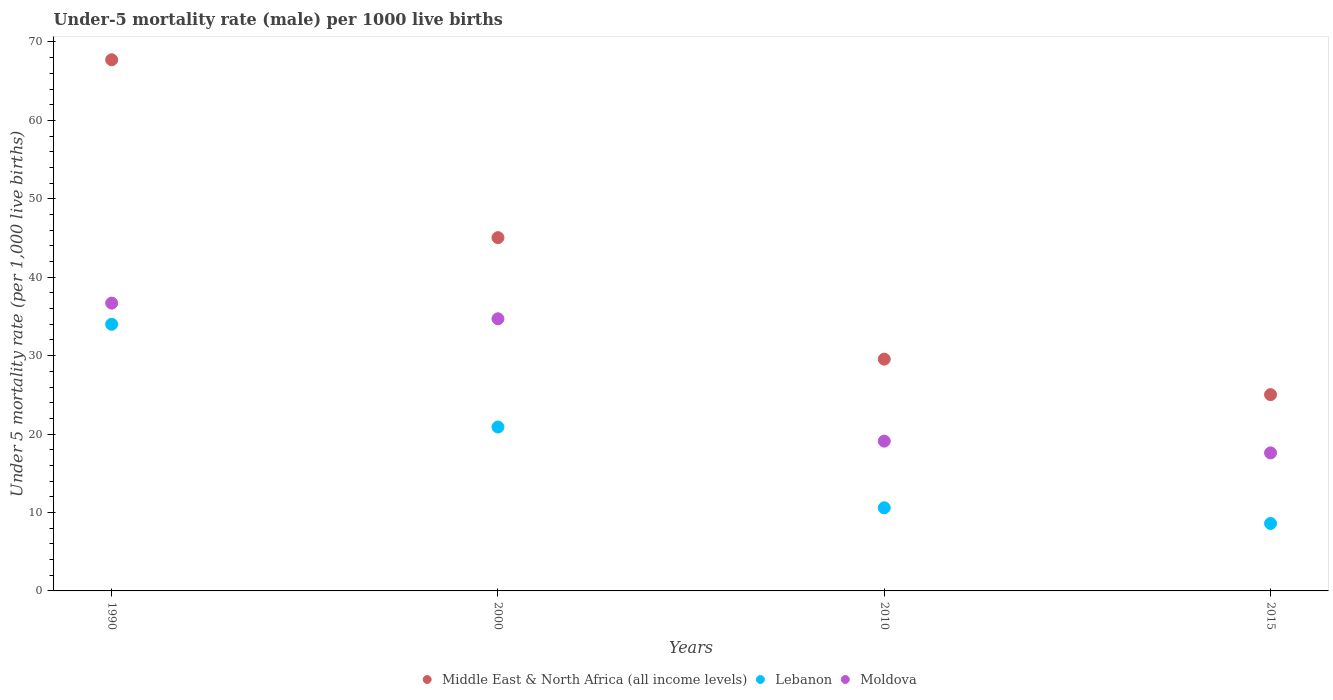What is the under-five mortality rate in Lebanon in 2010?
Your answer should be very brief. 10.6. Across all years, what is the maximum under-five mortality rate in Middle East & North Africa (all income levels)?
Offer a very short reply. 67.73. In which year was the under-five mortality rate in Lebanon minimum?
Your answer should be very brief. 2015. What is the total under-five mortality rate in Middle East & North Africa (all income levels) in the graph?
Your answer should be compact. 167.36. What is the difference between the under-five mortality rate in Lebanon in 1990 and that in 2015?
Your answer should be very brief. 25.4. What is the difference between the under-five mortality rate in Lebanon in 1990 and the under-five mortality rate in Moldova in 2000?
Your response must be concise. -0.7. What is the average under-five mortality rate in Middle East & North Africa (all income levels) per year?
Your answer should be compact. 41.84. In the year 2010, what is the difference between the under-five mortality rate in Lebanon and under-five mortality rate in Middle East & North Africa (all income levels)?
Make the answer very short. -18.96. What is the ratio of the under-five mortality rate in Middle East & North Africa (all income levels) in 1990 to that in 2010?
Make the answer very short. 2.29. Is the difference between the under-five mortality rate in Lebanon in 2010 and 2015 greater than the difference between the under-five mortality rate in Middle East & North Africa (all income levels) in 2010 and 2015?
Your response must be concise. No. What is the difference between the highest and the second highest under-five mortality rate in Moldova?
Provide a succinct answer. 2. What is the difference between the highest and the lowest under-five mortality rate in Moldova?
Offer a terse response. 19.1. Is the sum of the under-five mortality rate in Moldova in 1990 and 2010 greater than the maximum under-five mortality rate in Middle East & North Africa (all income levels) across all years?
Give a very brief answer. No. Is it the case that in every year, the sum of the under-five mortality rate in Moldova and under-five mortality rate in Lebanon  is greater than the under-five mortality rate in Middle East & North Africa (all income levels)?
Keep it short and to the point. Yes. Is the under-five mortality rate in Middle East & North Africa (all income levels) strictly less than the under-five mortality rate in Moldova over the years?
Offer a terse response. No. How many dotlines are there?
Your answer should be compact. 3. What is the difference between two consecutive major ticks on the Y-axis?
Keep it short and to the point. 10. Does the graph contain grids?
Provide a succinct answer. No. What is the title of the graph?
Your response must be concise. Under-5 mortality rate (male) per 1000 live births. Does "Angola" appear as one of the legend labels in the graph?
Make the answer very short. No. What is the label or title of the X-axis?
Make the answer very short. Years. What is the label or title of the Y-axis?
Provide a succinct answer. Under 5 mortality rate (per 1,0 live births). What is the Under 5 mortality rate (per 1,000 live births) of Middle East & North Africa (all income levels) in 1990?
Provide a succinct answer. 67.73. What is the Under 5 mortality rate (per 1,000 live births) of Lebanon in 1990?
Make the answer very short. 34. What is the Under 5 mortality rate (per 1,000 live births) of Moldova in 1990?
Ensure brevity in your answer.  36.7. What is the Under 5 mortality rate (per 1,000 live births) in Middle East & North Africa (all income levels) in 2000?
Your response must be concise. 45.05. What is the Under 5 mortality rate (per 1,000 live births) in Lebanon in 2000?
Provide a short and direct response. 20.9. What is the Under 5 mortality rate (per 1,000 live births) of Moldova in 2000?
Your answer should be very brief. 34.7. What is the Under 5 mortality rate (per 1,000 live births) of Middle East & North Africa (all income levels) in 2010?
Give a very brief answer. 29.56. What is the Under 5 mortality rate (per 1,000 live births) in Middle East & North Africa (all income levels) in 2015?
Keep it short and to the point. 25.03. What is the Under 5 mortality rate (per 1,000 live births) of Lebanon in 2015?
Your answer should be very brief. 8.6. What is the Under 5 mortality rate (per 1,000 live births) in Moldova in 2015?
Your response must be concise. 17.6. Across all years, what is the maximum Under 5 mortality rate (per 1,000 live births) in Middle East & North Africa (all income levels)?
Your response must be concise. 67.73. Across all years, what is the maximum Under 5 mortality rate (per 1,000 live births) of Lebanon?
Make the answer very short. 34. Across all years, what is the maximum Under 5 mortality rate (per 1,000 live births) in Moldova?
Provide a short and direct response. 36.7. Across all years, what is the minimum Under 5 mortality rate (per 1,000 live births) of Middle East & North Africa (all income levels)?
Keep it short and to the point. 25.03. Across all years, what is the minimum Under 5 mortality rate (per 1,000 live births) of Lebanon?
Keep it short and to the point. 8.6. What is the total Under 5 mortality rate (per 1,000 live births) in Middle East & North Africa (all income levels) in the graph?
Keep it short and to the point. 167.36. What is the total Under 5 mortality rate (per 1,000 live births) of Lebanon in the graph?
Keep it short and to the point. 74.1. What is the total Under 5 mortality rate (per 1,000 live births) of Moldova in the graph?
Make the answer very short. 108.1. What is the difference between the Under 5 mortality rate (per 1,000 live births) in Middle East & North Africa (all income levels) in 1990 and that in 2000?
Make the answer very short. 22.68. What is the difference between the Under 5 mortality rate (per 1,000 live births) of Lebanon in 1990 and that in 2000?
Keep it short and to the point. 13.1. What is the difference between the Under 5 mortality rate (per 1,000 live births) of Middle East & North Africa (all income levels) in 1990 and that in 2010?
Your answer should be compact. 38.17. What is the difference between the Under 5 mortality rate (per 1,000 live births) in Lebanon in 1990 and that in 2010?
Give a very brief answer. 23.4. What is the difference between the Under 5 mortality rate (per 1,000 live births) in Middle East & North Africa (all income levels) in 1990 and that in 2015?
Keep it short and to the point. 42.7. What is the difference between the Under 5 mortality rate (per 1,000 live births) in Lebanon in 1990 and that in 2015?
Your answer should be compact. 25.4. What is the difference between the Under 5 mortality rate (per 1,000 live births) of Middle East & North Africa (all income levels) in 2000 and that in 2010?
Provide a succinct answer. 15.49. What is the difference between the Under 5 mortality rate (per 1,000 live births) in Lebanon in 2000 and that in 2010?
Make the answer very short. 10.3. What is the difference between the Under 5 mortality rate (per 1,000 live births) of Moldova in 2000 and that in 2010?
Your answer should be compact. 15.6. What is the difference between the Under 5 mortality rate (per 1,000 live births) of Middle East & North Africa (all income levels) in 2000 and that in 2015?
Your answer should be compact. 20.02. What is the difference between the Under 5 mortality rate (per 1,000 live births) in Lebanon in 2000 and that in 2015?
Provide a short and direct response. 12.3. What is the difference between the Under 5 mortality rate (per 1,000 live births) of Middle East & North Africa (all income levels) in 2010 and that in 2015?
Make the answer very short. 4.53. What is the difference between the Under 5 mortality rate (per 1,000 live births) in Middle East & North Africa (all income levels) in 1990 and the Under 5 mortality rate (per 1,000 live births) in Lebanon in 2000?
Make the answer very short. 46.83. What is the difference between the Under 5 mortality rate (per 1,000 live births) of Middle East & North Africa (all income levels) in 1990 and the Under 5 mortality rate (per 1,000 live births) of Moldova in 2000?
Your response must be concise. 33.03. What is the difference between the Under 5 mortality rate (per 1,000 live births) of Lebanon in 1990 and the Under 5 mortality rate (per 1,000 live births) of Moldova in 2000?
Give a very brief answer. -0.7. What is the difference between the Under 5 mortality rate (per 1,000 live births) in Middle East & North Africa (all income levels) in 1990 and the Under 5 mortality rate (per 1,000 live births) in Lebanon in 2010?
Provide a succinct answer. 57.13. What is the difference between the Under 5 mortality rate (per 1,000 live births) of Middle East & North Africa (all income levels) in 1990 and the Under 5 mortality rate (per 1,000 live births) of Moldova in 2010?
Make the answer very short. 48.63. What is the difference between the Under 5 mortality rate (per 1,000 live births) of Lebanon in 1990 and the Under 5 mortality rate (per 1,000 live births) of Moldova in 2010?
Make the answer very short. 14.9. What is the difference between the Under 5 mortality rate (per 1,000 live births) in Middle East & North Africa (all income levels) in 1990 and the Under 5 mortality rate (per 1,000 live births) in Lebanon in 2015?
Keep it short and to the point. 59.13. What is the difference between the Under 5 mortality rate (per 1,000 live births) of Middle East & North Africa (all income levels) in 1990 and the Under 5 mortality rate (per 1,000 live births) of Moldova in 2015?
Give a very brief answer. 50.13. What is the difference between the Under 5 mortality rate (per 1,000 live births) in Middle East & North Africa (all income levels) in 2000 and the Under 5 mortality rate (per 1,000 live births) in Lebanon in 2010?
Your answer should be very brief. 34.45. What is the difference between the Under 5 mortality rate (per 1,000 live births) of Middle East & North Africa (all income levels) in 2000 and the Under 5 mortality rate (per 1,000 live births) of Moldova in 2010?
Make the answer very short. 25.95. What is the difference between the Under 5 mortality rate (per 1,000 live births) of Middle East & North Africa (all income levels) in 2000 and the Under 5 mortality rate (per 1,000 live births) of Lebanon in 2015?
Your answer should be compact. 36.45. What is the difference between the Under 5 mortality rate (per 1,000 live births) of Middle East & North Africa (all income levels) in 2000 and the Under 5 mortality rate (per 1,000 live births) of Moldova in 2015?
Provide a succinct answer. 27.45. What is the difference between the Under 5 mortality rate (per 1,000 live births) of Middle East & North Africa (all income levels) in 2010 and the Under 5 mortality rate (per 1,000 live births) of Lebanon in 2015?
Provide a succinct answer. 20.96. What is the difference between the Under 5 mortality rate (per 1,000 live births) in Middle East & North Africa (all income levels) in 2010 and the Under 5 mortality rate (per 1,000 live births) in Moldova in 2015?
Provide a short and direct response. 11.96. What is the difference between the Under 5 mortality rate (per 1,000 live births) of Lebanon in 2010 and the Under 5 mortality rate (per 1,000 live births) of Moldova in 2015?
Provide a short and direct response. -7. What is the average Under 5 mortality rate (per 1,000 live births) in Middle East & North Africa (all income levels) per year?
Offer a terse response. 41.84. What is the average Under 5 mortality rate (per 1,000 live births) of Lebanon per year?
Ensure brevity in your answer.  18.52. What is the average Under 5 mortality rate (per 1,000 live births) in Moldova per year?
Your answer should be compact. 27.02. In the year 1990, what is the difference between the Under 5 mortality rate (per 1,000 live births) in Middle East & North Africa (all income levels) and Under 5 mortality rate (per 1,000 live births) in Lebanon?
Make the answer very short. 33.73. In the year 1990, what is the difference between the Under 5 mortality rate (per 1,000 live births) in Middle East & North Africa (all income levels) and Under 5 mortality rate (per 1,000 live births) in Moldova?
Give a very brief answer. 31.03. In the year 2000, what is the difference between the Under 5 mortality rate (per 1,000 live births) of Middle East & North Africa (all income levels) and Under 5 mortality rate (per 1,000 live births) of Lebanon?
Provide a short and direct response. 24.15. In the year 2000, what is the difference between the Under 5 mortality rate (per 1,000 live births) in Middle East & North Africa (all income levels) and Under 5 mortality rate (per 1,000 live births) in Moldova?
Make the answer very short. 10.35. In the year 2000, what is the difference between the Under 5 mortality rate (per 1,000 live births) in Lebanon and Under 5 mortality rate (per 1,000 live births) in Moldova?
Your response must be concise. -13.8. In the year 2010, what is the difference between the Under 5 mortality rate (per 1,000 live births) of Middle East & North Africa (all income levels) and Under 5 mortality rate (per 1,000 live births) of Lebanon?
Provide a short and direct response. 18.96. In the year 2010, what is the difference between the Under 5 mortality rate (per 1,000 live births) of Middle East & North Africa (all income levels) and Under 5 mortality rate (per 1,000 live births) of Moldova?
Provide a succinct answer. 10.46. In the year 2010, what is the difference between the Under 5 mortality rate (per 1,000 live births) in Lebanon and Under 5 mortality rate (per 1,000 live births) in Moldova?
Your answer should be very brief. -8.5. In the year 2015, what is the difference between the Under 5 mortality rate (per 1,000 live births) of Middle East & North Africa (all income levels) and Under 5 mortality rate (per 1,000 live births) of Lebanon?
Keep it short and to the point. 16.43. In the year 2015, what is the difference between the Under 5 mortality rate (per 1,000 live births) in Middle East & North Africa (all income levels) and Under 5 mortality rate (per 1,000 live births) in Moldova?
Your response must be concise. 7.43. In the year 2015, what is the difference between the Under 5 mortality rate (per 1,000 live births) in Lebanon and Under 5 mortality rate (per 1,000 live births) in Moldova?
Give a very brief answer. -9. What is the ratio of the Under 5 mortality rate (per 1,000 live births) in Middle East & North Africa (all income levels) in 1990 to that in 2000?
Ensure brevity in your answer.  1.5. What is the ratio of the Under 5 mortality rate (per 1,000 live births) of Lebanon in 1990 to that in 2000?
Your answer should be very brief. 1.63. What is the ratio of the Under 5 mortality rate (per 1,000 live births) in Moldova in 1990 to that in 2000?
Offer a terse response. 1.06. What is the ratio of the Under 5 mortality rate (per 1,000 live births) in Middle East & North Africa (all income levels) in 1990 to that in 2010?
Keep it short and to the point. 2.29. What is the ratio of the Under 5 mortality rate (per 1,000 live births) in Lebanon in 1990 to that in 2010?
Your answer should be compact. 3.21. What is the ratio of the Under 5 mortality rate (per 1,000 live births) in Moldova in 1990 to that in 2010?
Provide a succinct answer. 1.92. What is the ratio of the Under 5 mortality rate (per 1,000 live births) in Middle East & North Africa (all income levels) in 1990 to that in 2015?
Keep it short and to the point. 2.71. What is the ratio of the Under 5 mortality rate (per 1,000 live births) in Lebanon in 1990 to that in 2015?
Your answer should be compact. 3.95. What is the ratio of the Under 5 mortality rate (per 1,000 live births) in Moldova in 1990 to that in 2015?
Give a very brief answer. 2.09. What is the ratio of the Under 5 mortality rate (per 1,000 live births) of Middle East & North Africa (all income levels) in 2000 to that in 2010?
Ensure brevity in your answer.  1.52. What is the ratio of the Under 5 mortality rate (per 1,000 live births) in Lebanon in 2000 to that in 2010?
Your answer should be very brief. 1.97. What is the ratio of the Under 5 mortality rate (per 1,000 live births) of Moldova in 2000 to that in 2010?
Give a very brief answer. 1.82. What is the ratio of the Under 5 mortality rate (per 1,000 live births) in Middle East & North Africa (all income levels) in 2000 to that in 2015?
Make the answer very short. 1.8. What is the ratio of the Under 5 mortality rate (per 1,000 live births) in Lebanon in 2000 to that in 2015?
Your response must be concise. 2.43. What is the ratio of the Under 5 mortality rate (per 1,000 live births) of Moldova in 2000 to that in 2015?
Your answer should be compact. 1.97. What is the ratio of the Under 5 mortality rate (per 1,000 live births) of Middle East & North Africa (all income levels) in 2010 to that in 2015?
Ensure brevity in your answer.  1.18. What is the ratio of the Under 5 mortality rate (per 1,000 live births) of Lebanon in 2010 to that in 2015?
Your answer should be compact. 1.23. What is the ratio of the Under 5 mortality rate (per 1,000 live births) of Moldova in 2010 to that in 2015?
Keep it short and to the point. 1.09. What is the difference between the highest and the second highest Under 5 mortality rate (per 1,000 live births) of Middle East & North Africa (all income levels)?
Make the answer very short. 22.68. What is the difference between the highest and the second highest Under 5 mortality rate (per 1,000 live births) in Lebanon?
Keep it short and to the point. 13.1. What is the difference between the highest and the lowest Under 5 mortality rate (per 1,000 live births) of Middle East & North Africa (all income levels)?
Your response must be concise. 42.7. What is the difference between the highest and the lowest Under 5 mortality rate (per 1,000 live births) in Lebanon?
Your answer should be compact. 25.4. What is the difference between the highest and the lowest Under 5 mortality rate (per 1,000 live births) in Moldova?
Keep it short and to the point. 19.1. 